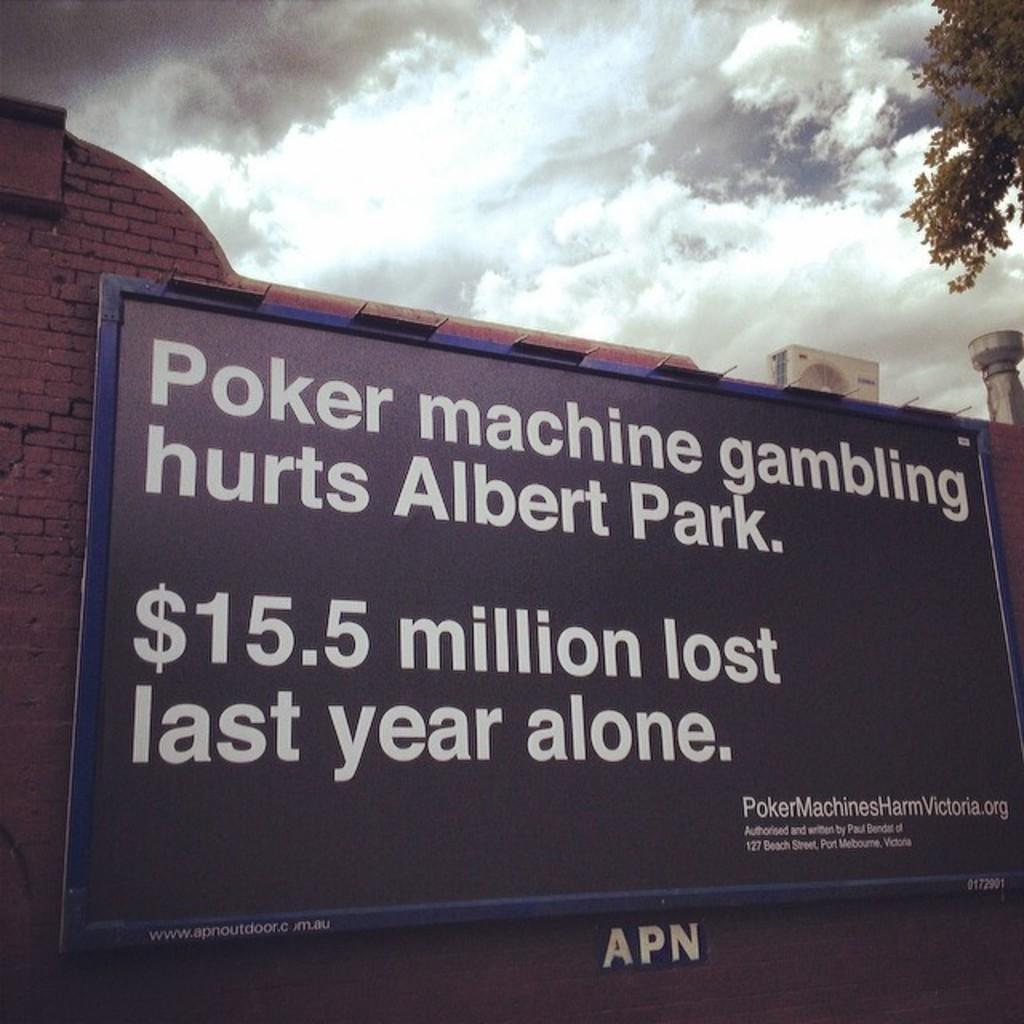In one or two sentences, can you explain what this image depicts? In the foreground of the picture there is a board. On the left there is a brick wall. At the top towards right there are three, air conditioner and a pole. At the top there is sky. 